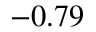<formula> <loc_0><loc_0><loc_500><loc_500>- 0 . 7 9</formula> 